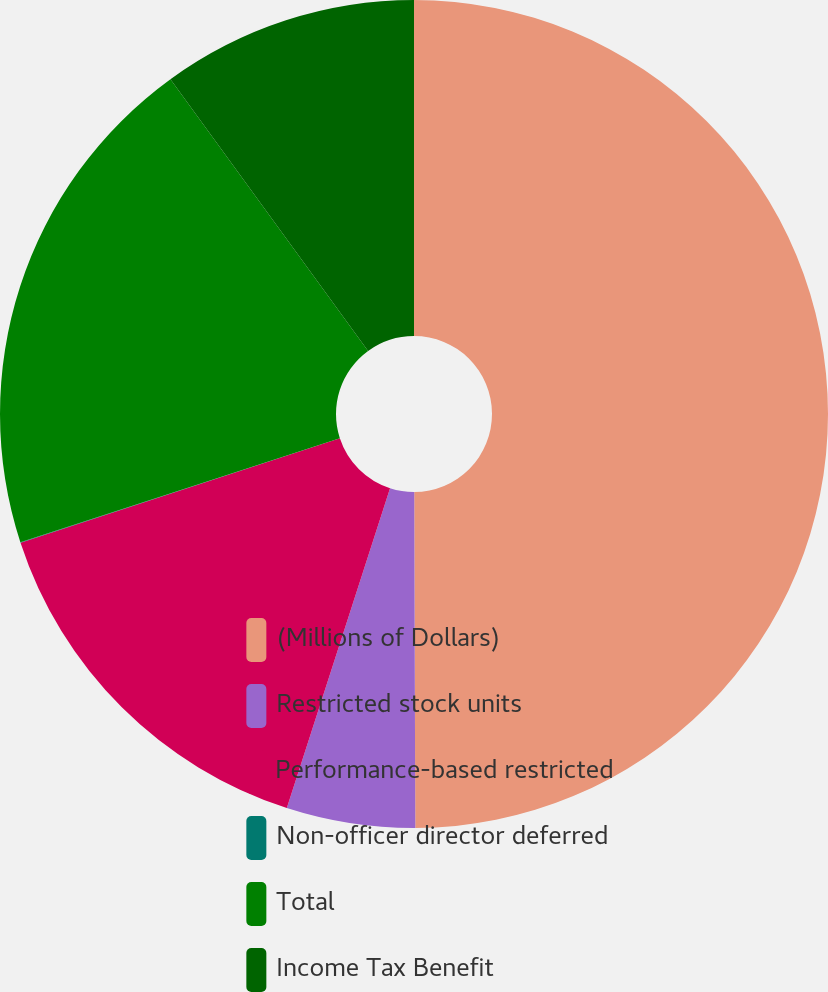<chart> <loc_0><loc_0><loc_500><loc_500><pie_chart><fcel>(Millions of Dollars)<fcel>Restricted stock units<fcel>Performance-based restricted<fcel>Non-officer director deferred<fcel>Total<fcel>Income Tax Benefit<nl><fcel>49.95%<fcel>5.02%<fcel>15.0%<fcel>0.02%<fcel>20.0%<fcel>10.01%<nl></chart> 